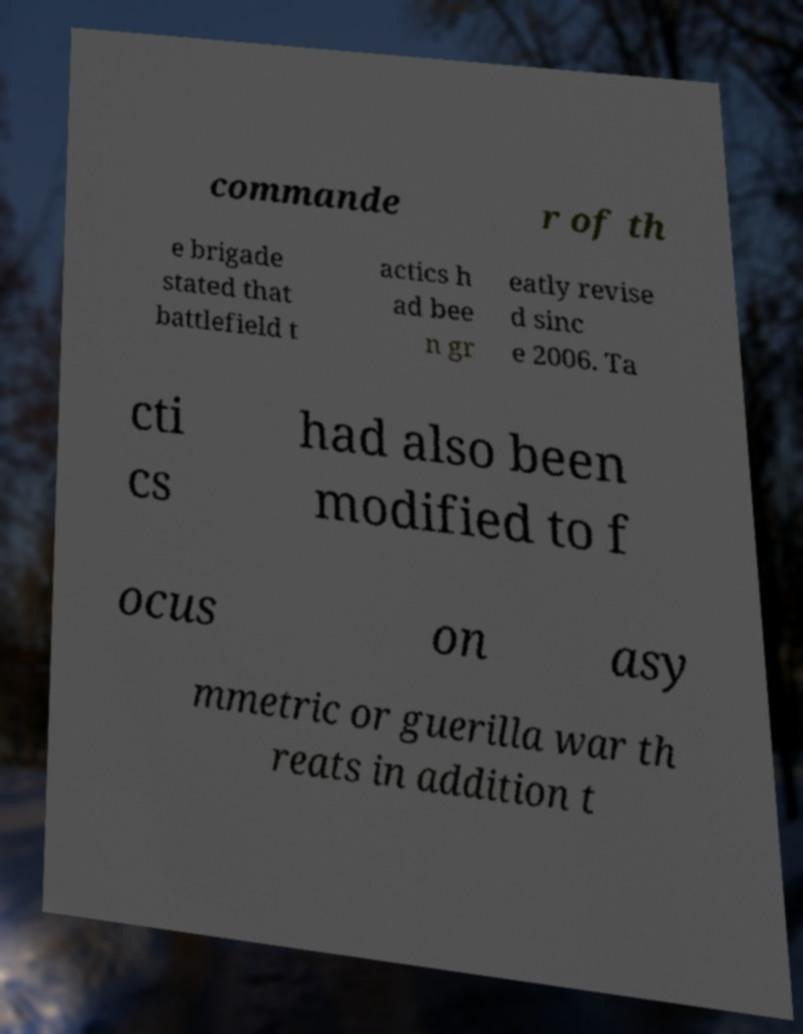I need the written content from this picture converted into text. Can you do that? commande r of th e brigade stated that battlefield t actics h ad bee n gr eatly revise d sinc e 2006. Ta cti cs had also been modified to f ocus on asy mmetric or guerilla war th reats in addition t 